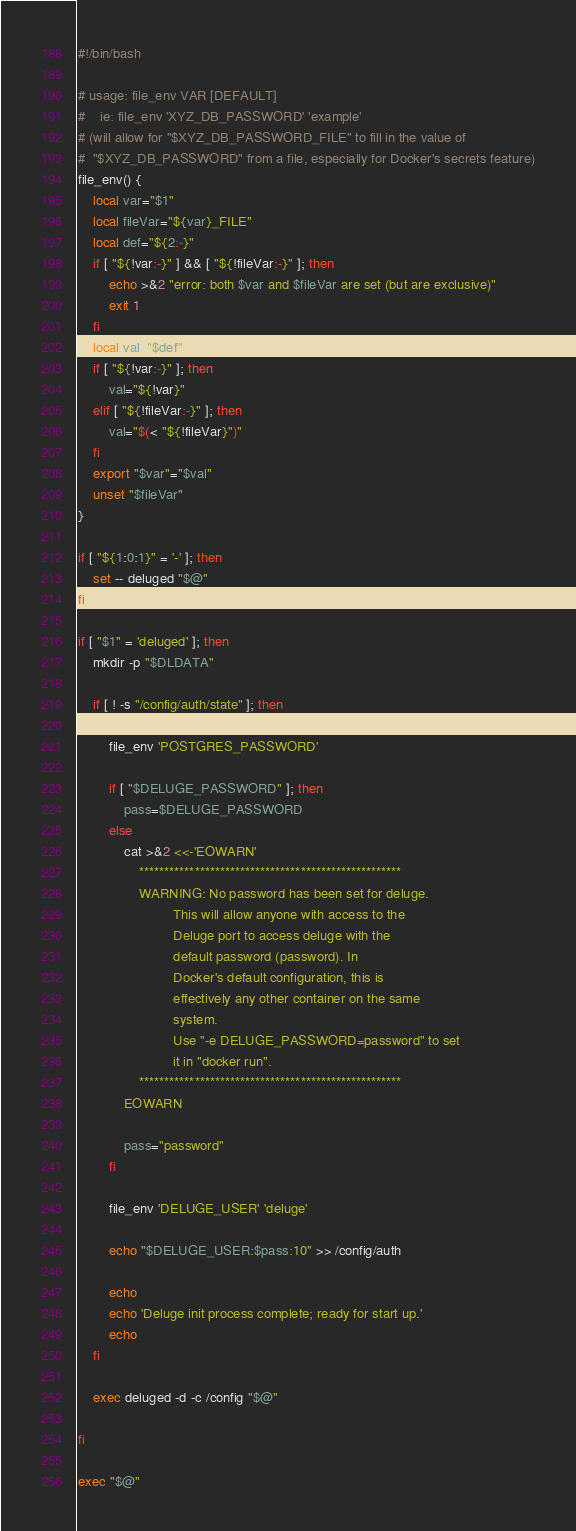<code> <loc_0><loc_0><loc_500><loc_500><_Bash_>#!/bin/bash

# usage: file_env VAR [DEFAULT]
#    ie: file_env 'XYZ_DB_PASSWORD' 'example'
# (will allow for "$XYZ_DB_PASSWORD_FILE" to fill in the value of
#  "$XYZ_DB_PASSWORD" from a file, especially for Docker's secrets feature)
file_env() {
	local var="$1"
	local fileVar="${var}_FILE"
	local def="${2:-}"
	if [ "${!var:-}" ] && [ "${!fileVar:-}" ]; then
		echo >&2 "error: both $var and $fileVar are set (but are exclusive)"
		exit 1
	fi
	local val="$def"
	if [ "${!var:-}" ]; then
		val="${!var}"
	elif [ "${!fileVar:-}" ]; then
		val="$(< "${!fileVar}")"
	fi
	export "$var"="$val"
	unset "$fileVar"
}

if [ "${1:0:1}" = '-' ]; then
	set -- deluged "$@"
fi

if [ "$1" = 'deluged' ]; then
	mkdir -p "$DLDATA"

	if [ ! -s "/config/auth/state" ]; then

		file_env 'POSTGRES_PASSWORD'

		if [ "$DELUGE_PASSWORD" ]; then
			pass=$DELUGE_PASSWORD
		else
			cat >&2 <<-'EOWARN'
				****************************************************
				WARNING: No password has been set for deluge.
				         This will allow anyone with access to the
				         Deluge port to access deluge with the 
				         default password (password). In
				         Docker's default configuration, this is
				         effectively any other container on the same
				         system.
				         Use "-e DELUGE_PASSWORD=password" to set
				         it in "docker run".
				****************************************************
			EOWARN

			pass="password"
		fi

		file_env 'DELUGE_USER' 'deluge'

		echo "$DELUGE_USER:$pass:10" >> /config/auth

		echo
		echo 'Deluge init process complete; ready for start up.'
		echo
	fi

	exec deluged -d -c /config "$@"

fi

exec "$@"

</code> 